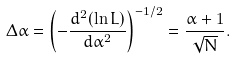<formula> <loc_0><loc_0><loc_500><loc_500>\Delta \alpha = \left ( - \frac { d ^ { 2 } ( \ln L ) } { d \alpha ^ { 2 } } \right ) ^ { - 1 / 2 } = \frac { \alpha + 1 } { \sqrt { N } } .</formula> 